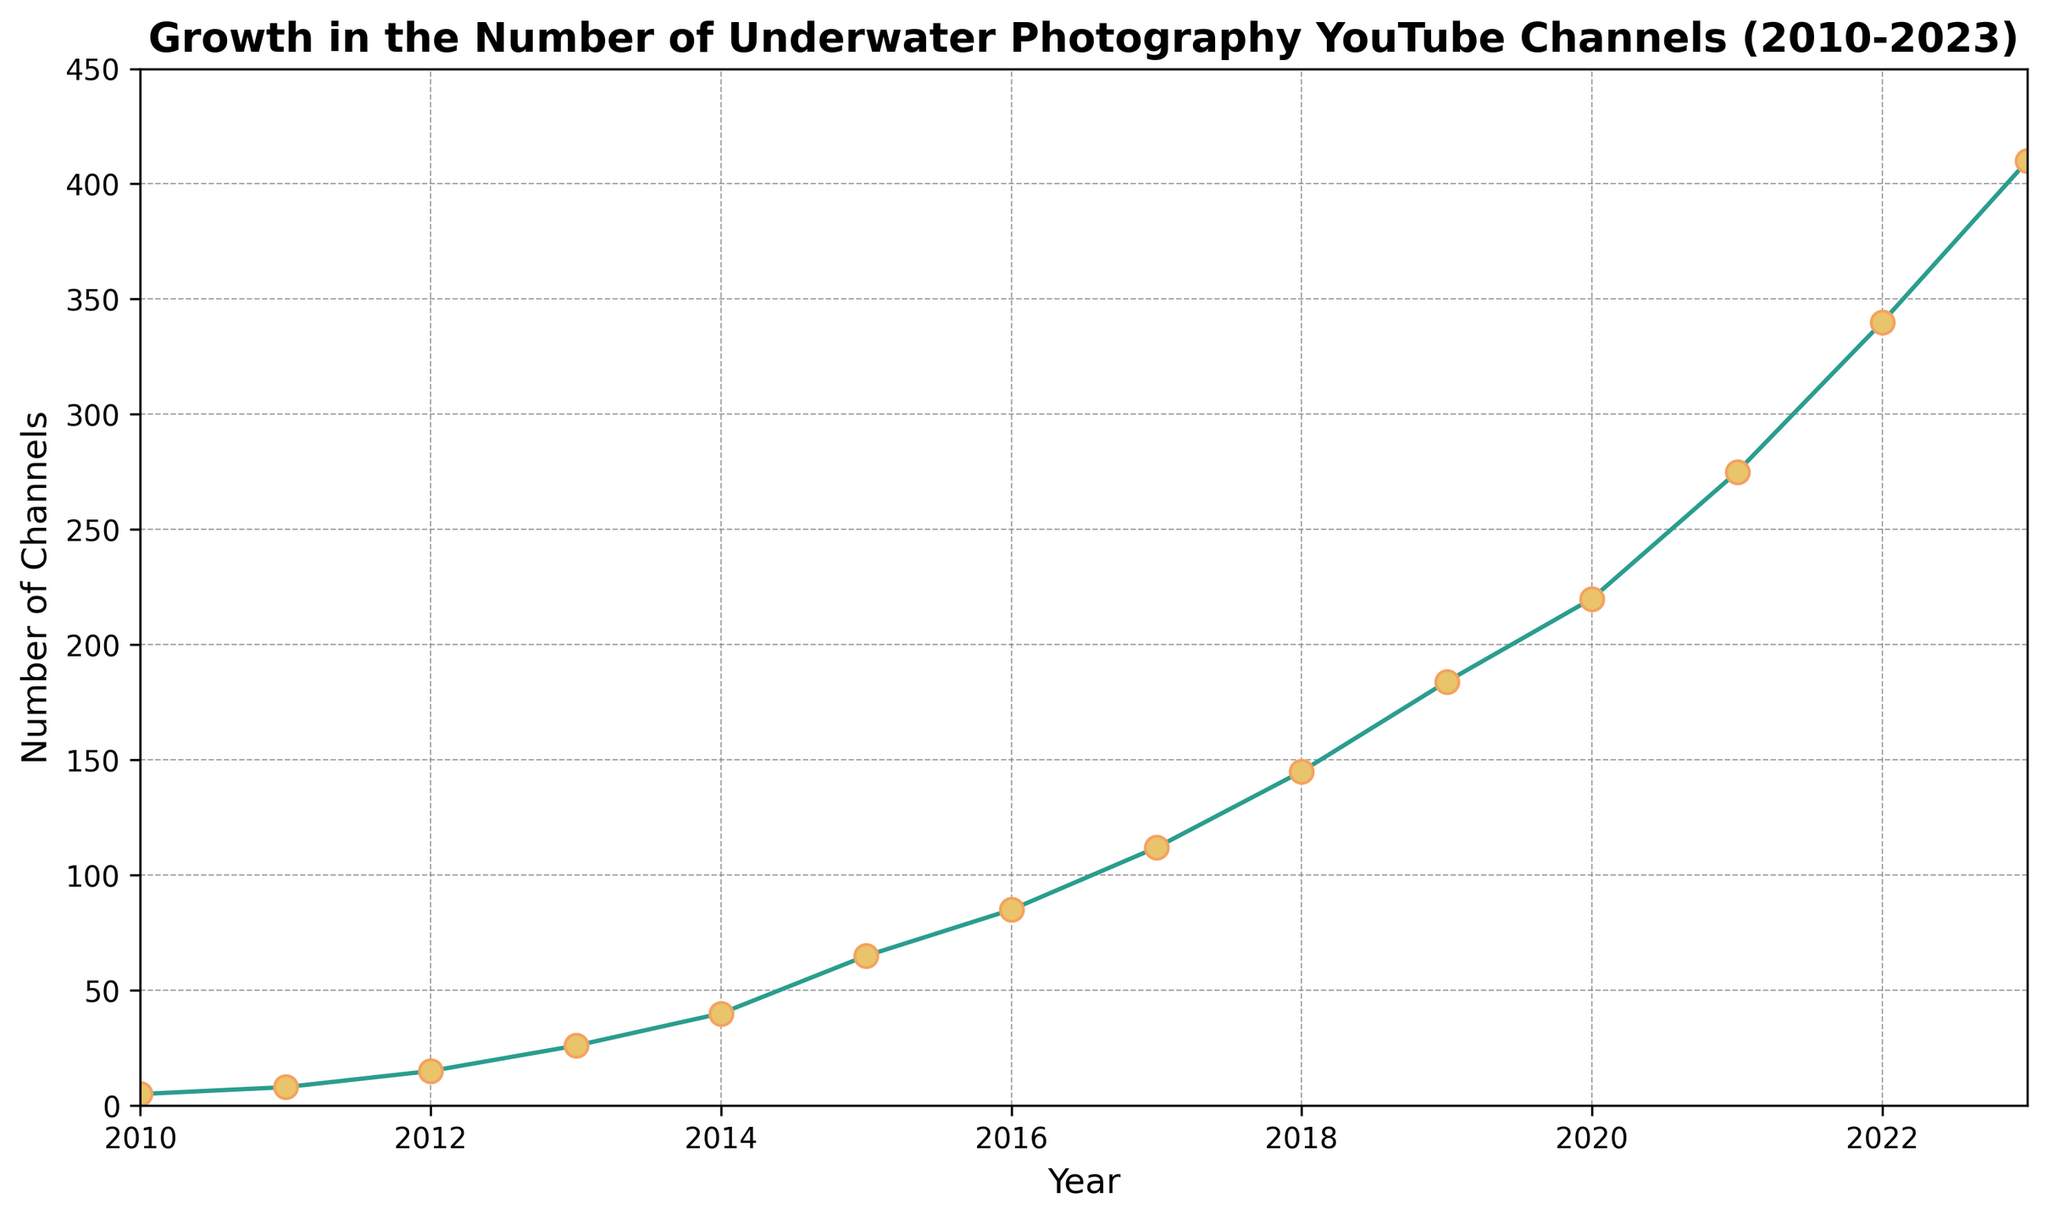What is the overall trend in the number of underwater photography YouTube channels from 2010 to 2023? The line chart shows a steady increase in the number of underwater photography YouTube channels each year from 2010 to 2023. The trend is upward, indicating growth in the number of channels over the years.
Answer: Upward Which year experienced the largest increase in the number of underwater photography YouTube channels? To find the year with the largest increase, we need to look at the differences in the number of channels between consecutive years. The most significant increase occurs between 2021 and 2022, where the number of channels increased from 275 to 340, a difference of 65 channels.
Answer: 2021 to 2022 How many underwater photography YouTube channels were there in 2015? Simply refer to the data point for the year 2015 on the chart, which shows the number of channels. In 2015, there were 65 channels.
Answer: 65 What is the growth rate of the underwater photography YouTube channels from 2010 to 2023? The growth rate can be calculated using the formula: [(Number of channels in 2023 - Number of channels in 2010) / Number of channels in 2010] * 100. Substituting the values: [(410 - 5) / 5] * 100 = 8100%.
Answer: 8100% How does the number of channels in 2018 compare to that in 2020? To compare the values, look at the number of channels in 2018 and 2020. In 2018, there were 145 channels, and in 2020, there were 220 channels. Comparing the two, 220 is greater than 145.
Answer: 2020 has more channels than 2018 By how much did the number of channels increase from 2010 to 2015? Calculate the difference in the number of channels between 2010 and 2015. In 2010, there were 5 channels, and in 2015, there were 65 channels. So, the increase is 65 - 5 = 60 channels.
Answer: 60 channels What is the average number of channels over the entire period from 2010 to 2023? The average number of channels is calculated by summing up the number of channels for all years and then dividing by the number of years. (5 + 8 + 15 + 26 + 40 + 65 + 85 + 112 + 145 + 184 + 220 + 275 + 340 + 410) / 14 = 140.14 channels.
Answer: 140.14 channels Which year had the smallest number of underwater photography YouTube channels? Look for the smallest data point on the chart. In 2010, there were only 5 channels, which is the smallest number over the years.
Answer: 2010 Is there any year where the growth in the number of channels stagnated or stayed constant? Examine the line chart for any flat parts where the number of channels did not increase. The chart shows continuous growth every year without any year of stagnation.
Answer: No What is the visual style of the markers used in the line chart? Notice the design elements of the markers. The chart uses circular markers (dots) that are filled with yellow and have a darker border, placed at each data point along the line.
Answer: Circular markers with yellow fill and darker border 